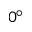Convert formula to latex. <formula><loc_0><loc_0><loc_500><loc_500>0 ^ { \circ }</formula> 